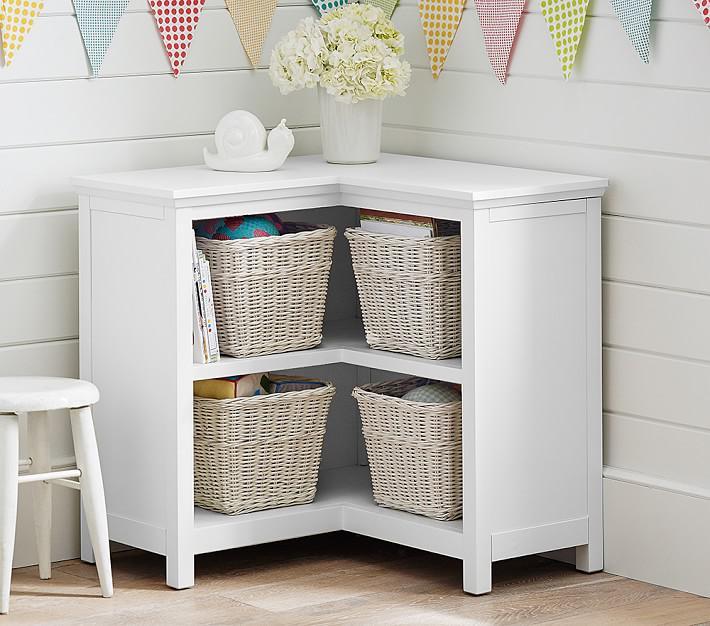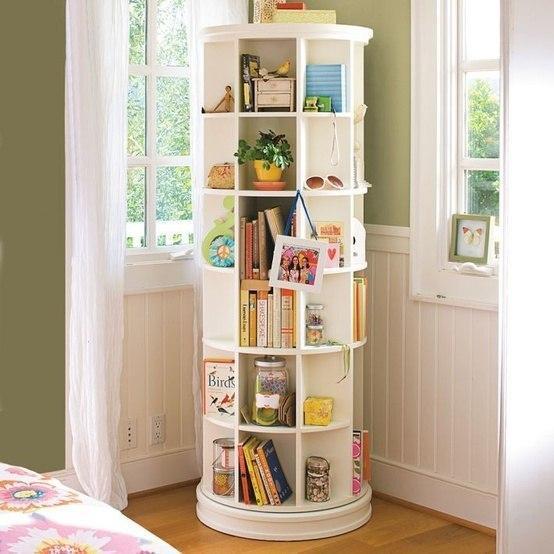The first image is the image on the left, the second image is the image on the right. Considering the images on both sides, is "A corner shelf unit is next to a window with long white drapes" valid? Answer yes or no. Yes. The first image is the image on the left, the second image is the image on the right. Assess this claim about the two images: "An image shows a right-angle white corner cabinet, with a solid back and five shelves.". Correct or not? Answer yes or no. No. 